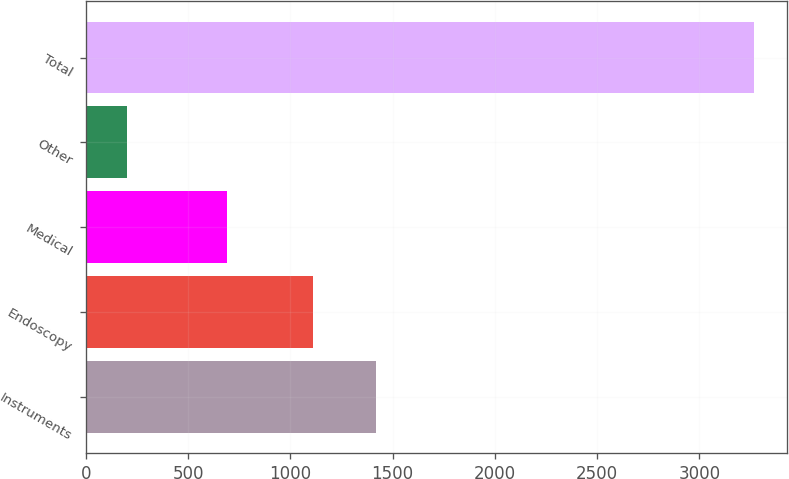<chart> <loc_0><loc_0><loc_500><loc_500><bar_chart><fcel>Instruments<fcel>Endoscopy<fcel>Medical<fcel>Other<fcel>Total<nl><fcel>1417.3<fcel>1111<fcel>691<fcel>202<fcel>3265<nl></chart> 